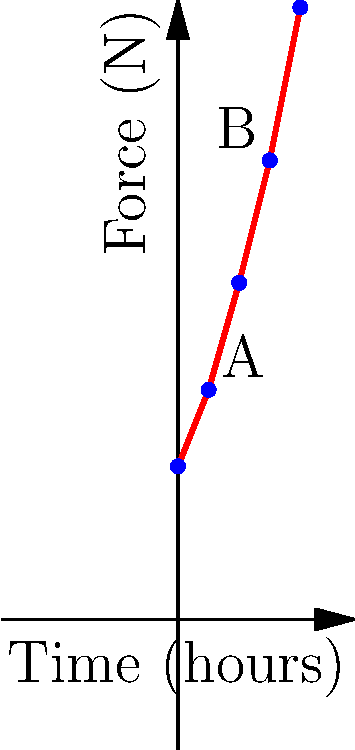The graph shows the force exerted on a journalist's wrist during prolonged typing. What is the percentage increase in force between points A and B, and how might this impact the transparency of reporting in long-form investigative journalism? To solve this problem, we need to follow these steps:

1. Identify the force values at points A and B:
   Point A (2 hours): 15 N
   Point B (6 hours): 30 N

2. Calculate the percentage increase:
   Percentage increase = $\frac{\text{Increase}}{\text{Original}} \times 100\%$
   
   $\text{Increase} = 30\text{ N} - 15\text{ N} = 15\text{ N}$
   
   Percentage increase = $\frac{15\text{ N}}{15\text{ N}} \times 100\% = 100\%$

3. Impact on transparency in long-form investigative journalism:
   - The 100% increase in force over 4 hours indicates a significant rise in physical strain.
   - This could lead to fatigue, discomfort, or even repetitive strain injuries.
   - Journalists may rush or cut corners in their work to alleviate physical discomfort.
   - The quality and depth of investigative reporting could be compromised, potentially affecting the transparency and thoroughness of the journalism.
   - Errors or omissions might occur due to physical stress, impacting the accuracy of reporting.
   - Journalists might be less inclined to pursue lengthy investigations, reducing overall transparency in media.
Answer: 100% increase; may compromise reporting quality and depth due to physical strain. 